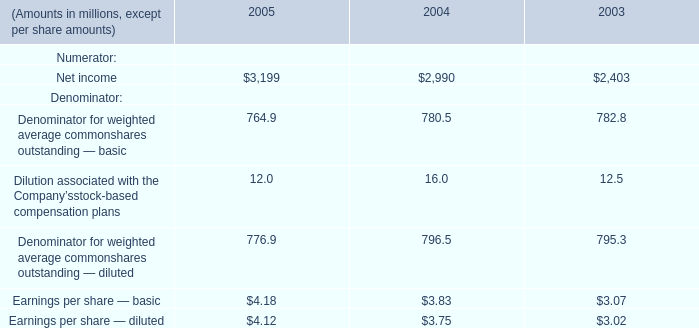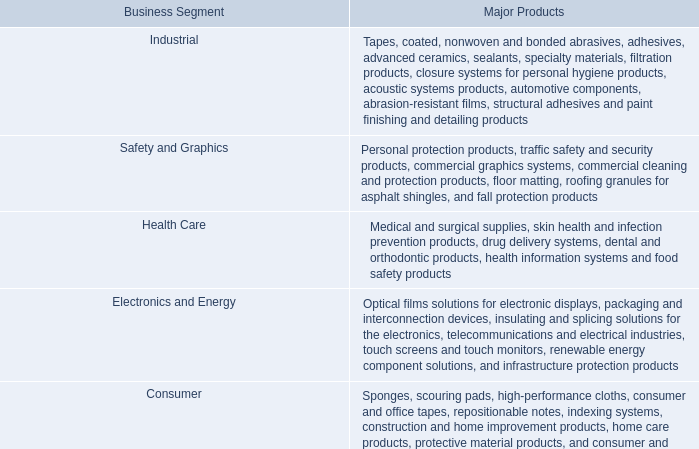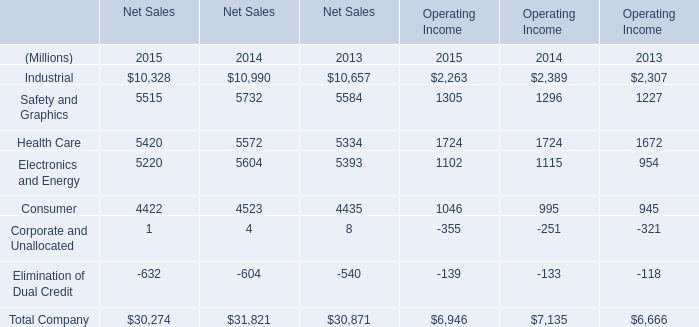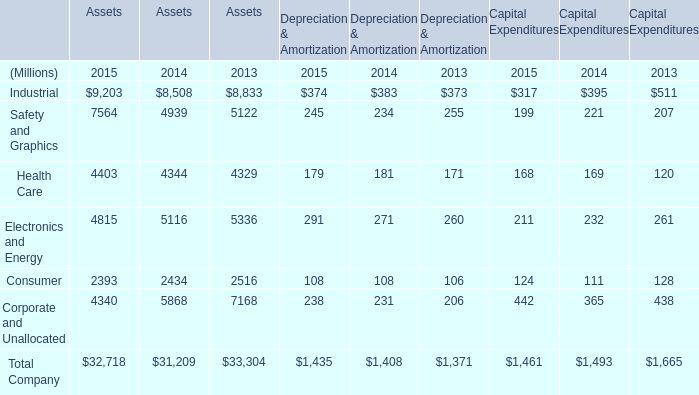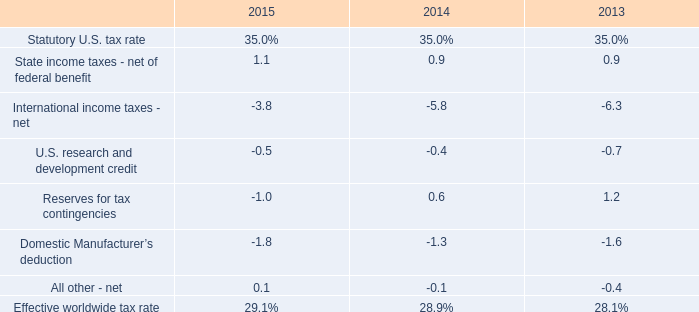In which year is Safety and Graphics for Assets greater than 7000? 
Answer: 2015. 